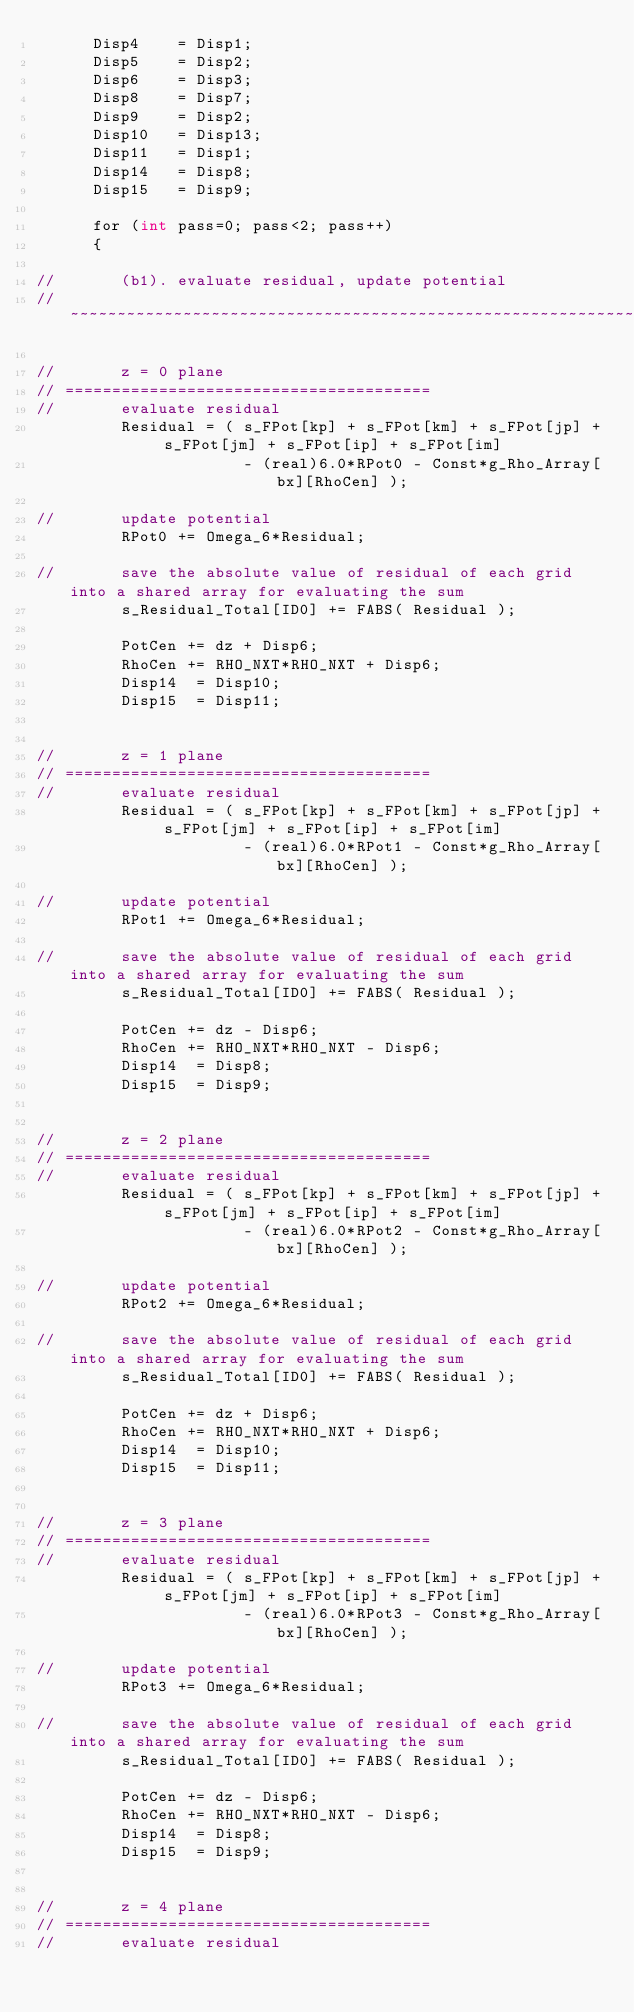Convert code to text. <code><loc_0><loc_0><loc_500><loc_500><_Cuda_>      Disp4    = Disp1;
      Disp5    = Disp2;
      Disp6    = Disp3;
      Disp8    = Disp7;
      Disp9    = Disp2;
      Disp10   = Disp13;
      Disp11   = Disp1;
      Disp14   = Disp8;
      Disp15   = Disp9;

      for (int pass=0; pass<2; pass++)
      {

//       (b1). evaluate residual, update potential
// ~~~~~~~~~~~~~~~~~~~~~~~~~~~~~~~~~~~~~~~~~~~~~~~~~~~~~~~~~~~~~~~~~~~~~~~~~~~~~~~~~~~~~~~~~~~~~~~

//       z = 0 plane
// =======================================
//       evaluate residual 
         Residual = ( s_FPot[kp] + s_FPot[km] + s_FPot[jp] + s_FPot[jm] + s_FPot[ip] + s_FPot[im]
                      - (real)6.0*RPot0 - Const*g_Rho_Array[bx][RhoCen] );

//       update potential
         RPot0 += Omega_6*Residual;

//       save the absolute value of residual of each grid into a shared array for evaluating the sum 
         s_Residual_Total[ID0] += FABS( Residual );

         PotCen += dz + Disp6;
         RhoCen += RHO_NXT*RHO_NXT + Disp6;
         Disp14  = Disp10;
         Disp15  = Disp11;


//       z = 1 plane
// =======================================
//       evaluate residual 
         Residual = ( s_FPot[kp] + s_FPot[km] + s_FPot[jp] + s_FPot[jm] + s_FPot[ip] + s_FPot[im]
                      - (real)6.0*RPot1 - Const*g_Rho_Array[bx][RhoCen] );

//       update potential
         RPot1 += Omega_6*Residual;

//       save the absolute value of residual of each grid into a shared array for evaluating the sum 
         s_Residual_Total[ID0] += FABS( Residual );

         PotCen += dz - Disp6;
         RhoCen += RHO_NXT*RHO_NXT - Disp6;
         Disp14  = Disp8;
         Disp15  = Disp9;


//       z = 2 plane
// =======================================
//       evaluate residual 
         Residual = ( s_FPot[kp] + s_FPot[km] + s_FPot[jp] + s_FPot[jm] + s_FPot[ip] + s_FPot[im]
                      - (real)6.0*RPot2 - Const*g_Rho_Array[bx][RhoCen] );

//       update potential
         RPot2 += Omega_6*Residual;

//       save the absolute value of residual of each grid into a shared array for evaluating the sum 
         s_Residual_Total[ID0] += FABS( Residual );

         PotCen += dz + Disp6;
         RhoCen += RHO_NXT*RHO_NXT + Disp6;
         Disp14  = Disp10;
         Disp15  = Disp11;


//       z = 3 plane
// =======================================
//       evaluate residual 
         Residual = ( s_FPot[kp] + s_FPot[km] + s_FPot[jp] + s_FPot[jm] + s_FPot[ip] + s_FPot[im]
                      - (real)6.0*RPot3 - Const*g_Rho_Array[bx][RhoCen] );

//       update potential
         RPot3 += Omega_6*Residual;

//       save the absolute value of residual of each grid into a shared array for evaluating the sum 
         s_Residual_Total[ID0] += FABS( Residual );

         PotCen += dz - Disp6;
         RhoCen += RHO_NXT*RHO_NXT - Disp6;
         Disp14  = Disp8;
         Disp15  = Disp9;


//       z = 4 plane
// =======================================
//       evaluate residual </code> 